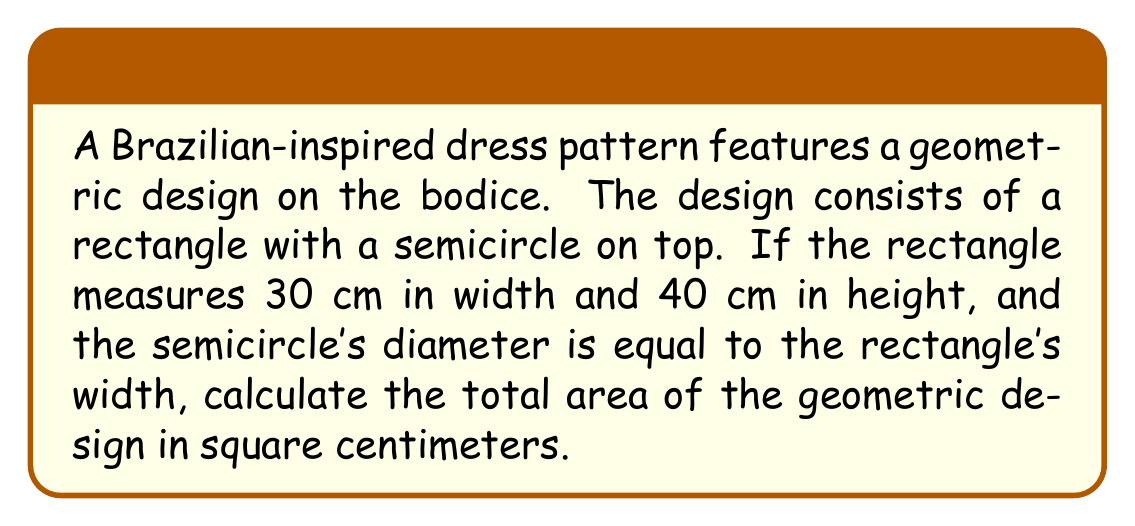Give your solution to this math problem. Let's break this down step-by-step:

1. Calculate the area of the rectangle:
   $$A_{rectangle} = width \times height = 30 \text{ cm} \times 40 \text{ cm} = 1200 \text{ cm}^2$$

2. Calculate the area of the semicircle:
   The radius of the semicircle is half the width of the rectangle:
   $$r = \frac{30 \text{ cm}}{2} = 15 \text{ cm}$$
   
   Area of a full circle: $$A_{circle} = \pi r^2$$
   Area of a semicircle: $$A_{semicircle} = \frac{1}{2} \pi r^2$$
   
   $$A_{semicircle} = \frac{1}{2} \pi (15 \text{ cm})^2 = \frac{1}{2} \pi (225 \text{ cm}^2) \approx 353.43 \text{ cm}^2$$

3. Sum the areas of the rectangle and semicircle:
   $$A_{total} = A_{rectangle} + A_{semicircle}$$
   $$A_{total} = 1200 \text{ cm}^2 + 353.43 \text{ cm}^2 = 1553.43 \text{ cm}^2$$

4. Round to the nearest whole number:
   $$A_{total} \approx 1553 \text{ cm}^2$$
Answer: 1553 cm² 